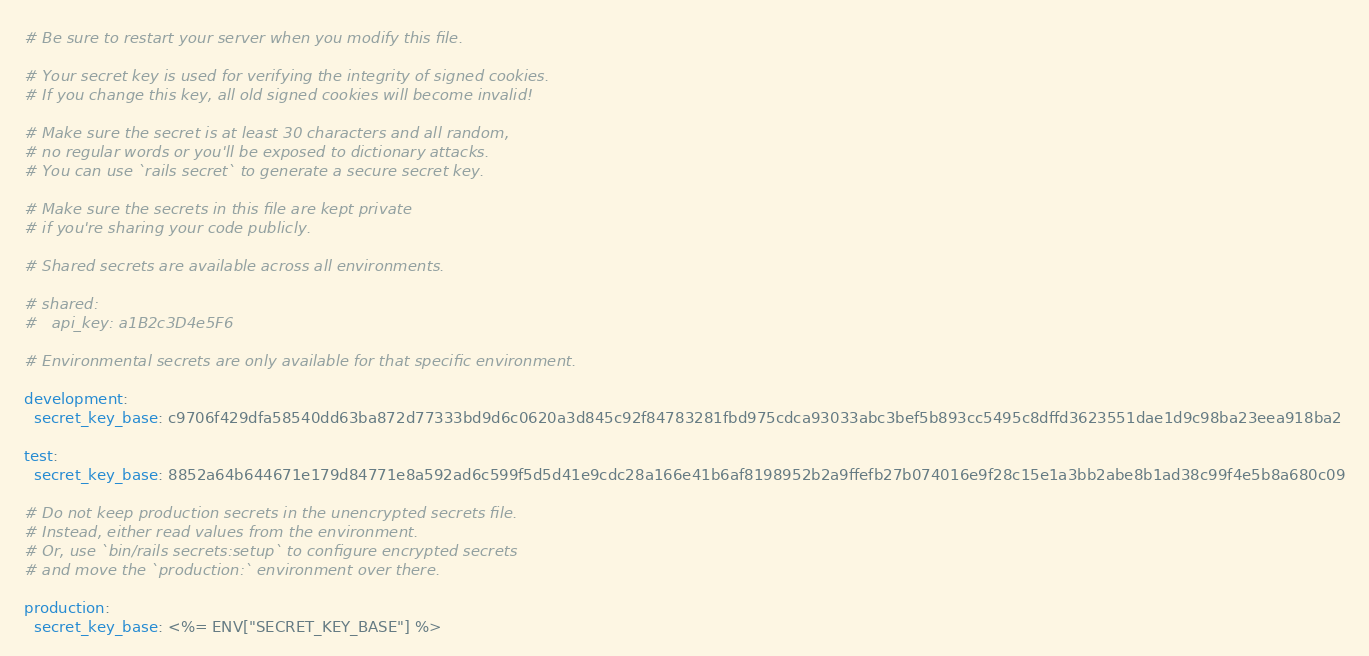<code> <loc_0><loc_0><loc_500><loc_500><_YAML_># Be sure to restart your server when you modify this file.

# Your secret key is used for verifying the integrity of signed cookies.
# If you change this key, all old signed cookies will become invalid!

# Make sure the secret is at least 30 characters and all random,
# no regular words or you'll be exposed to dictionary attacks.
# You can use `rails secret` to generate a secure secret key.

# Make sure the secrets in this file are kept private
# if you're sharing your code publicly.

# Shared secrets are available across all environments.

# shared:
#   api_key: a1B2c3D4e5F6

# Environmental secrets are only available for that specific environment.

development:
  secret_key_base: c9706f429dfa58540dd63ba872d77333bd9d6c0620a3d845c92f84783281fbd975cdca93033abc3bef5b893cc5495c8dffd3623551dae1d9c98ba23eea918ba2

test:
  secret_key_base: 8852a64b644671e179d84771e8a592ad6c599f5d5d41e9cdc28a166e41b6af8198952b2a9ffefb27b074016e9f28c15e1a3bb2abe8b1ad38c99f4e5b8a680c09

# Do not keep production secrets in the unencrypted secrets file.
# Instead, either read values from the environment.
# Or, use `bin/rails secrets:setup` to configure encrypted secrets
# and move the `production:` environment over there.

production:
  secret_key_base: <%= ENV["SECRET_KEY_BASE"] %>
</code> 